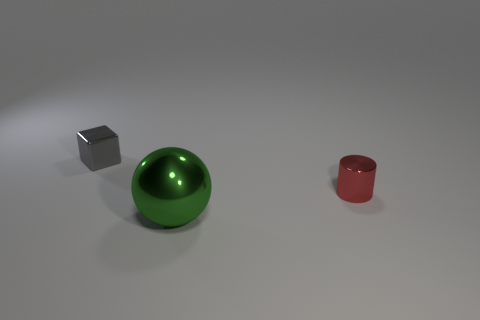Add 1 small objects. How many objects exist? 4 Subtract all cubes. How many objects are left? 2 Subtract 0 purple cylinders. How many objects are left? 3 Subtract all big yellow shiny objects. Subtract all tiny things. How many objects are left? 1 Add 3 small cubes. How many small cubes are left? 4 Add 2 tiny metal balls. How many tiny metal balls exist? 2 